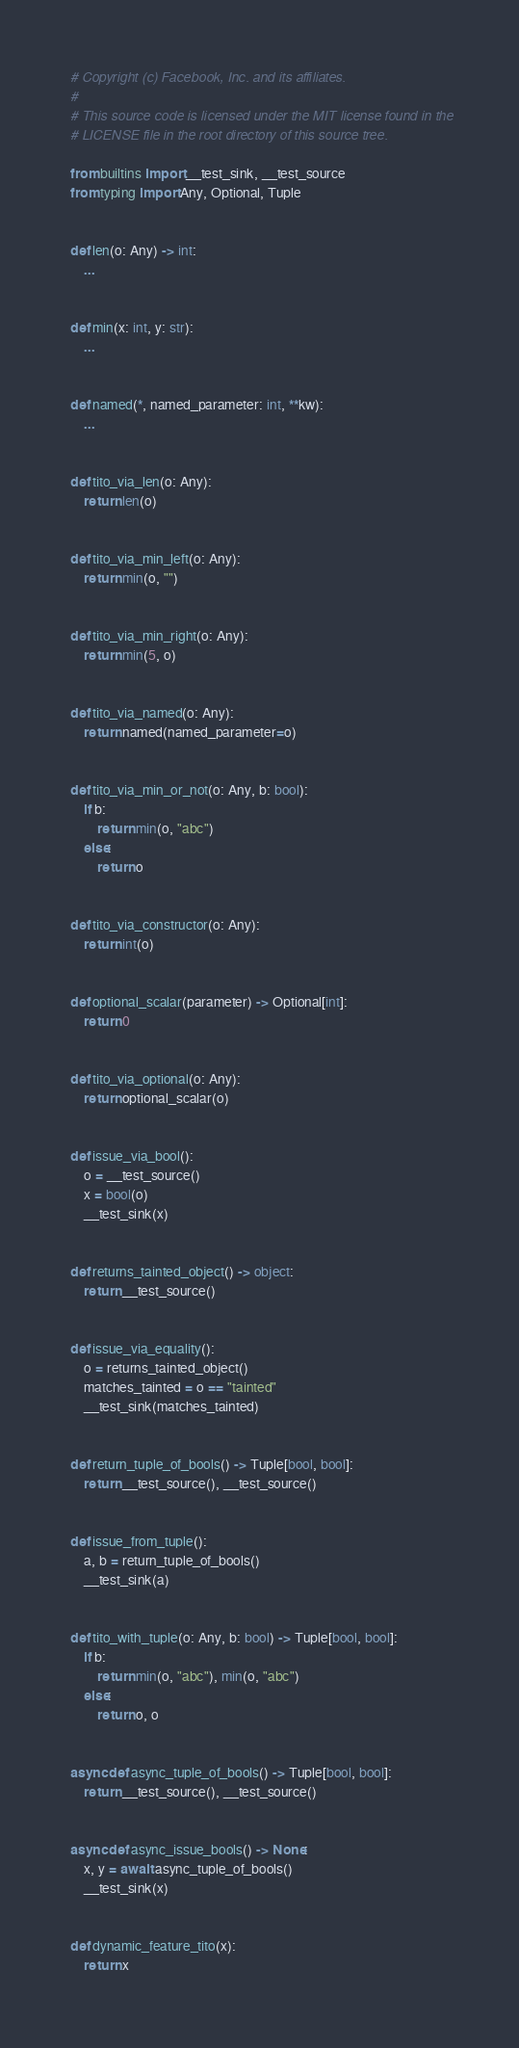Convert code to text. <code><loc_0><loc_0><loc_500><loc_500><_Python_># Copyright (c) Facebook, Inc. and its affiliates.
#
# This source code is licensed under the MIT license found in the
# LICENSE file in the root directory of this source tree.

from builtins import __test_sink, __test_source
from typing import Any, Optional, Tuple


def len(o: Any) -> int:
    ...


def min(x: int, y: str):
    ...


def named(*, named_parameter: int, **kw):
    ...


def tito_via_len(o: Any):
    return len(o)


def tito_via_min_left(o: Any):
    return min(o, "")


def tito_via_min_right(o: Any):
    return min(5, o)


def tito_via_named(o: Any):
    return named(named_parameter=o)


def tito_via_min_or_not(o: Any, b: bool):
    if b:
        return min(o, "abc")
    else:
        return o


def tito_via_constructor(o: Any):
    return int(o)


def optional_scalar(parameter) -> Optional[int]:
    return 0


def tito_via_optional(o: Any):
    return optional_scalar(o)


def issue_via_bool():
    o = __test_source()
    x = bool(o)
    __test_sink(x)


def returns_tainted_object() -> object:
    return __test_source()


def issue_via_equality():
    o = returns_tainted_object()
    matches_tainted = o == "tainted"
    __test_sink(matches_tainted)


def return_tuple_of_bools() -> Tuple[bool, bool]:
    return __test_source(), __test_source()


def issue_from_tuple():
    a, b = return_tuple_of_bools()
    __test_sink(a)


def tito_with_tuple(o: Any, b: bool) -> Tuple[bool, bool]:
    if b:
        return min(o, "abc"), min(o, "abc")
    else:
        return o, o


async def async_tuple_of_bools() -> Tuple[bool, bool]:
    return __test_source(), __test_source()


async def async_issue_bools() -> None:
    x, y = await async_tuple_of_bools()
    __test_sink(x)


def dynamic_feature_tito(x):
    return x
</code> 